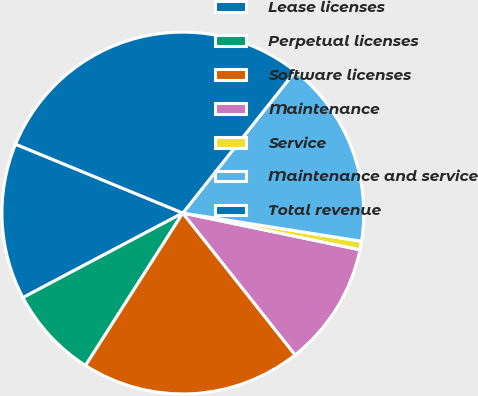<chart> <loc_0><loc_0><loc_500><loc_500><pie_chart><fcel>Lease licenses<fcel>Perpetual licenses<fcel>Software licenses<fcel>Maintenance<fcel>Service<fcel>Maintenance and service<fcel>Total revenue<nl><fcel>13.96%<fcel>8.22%<fcel>19.7%<fcel>11.09%<fcel>0.76%<fcel>16.83%<fcel>29.46%<nl></chart> 